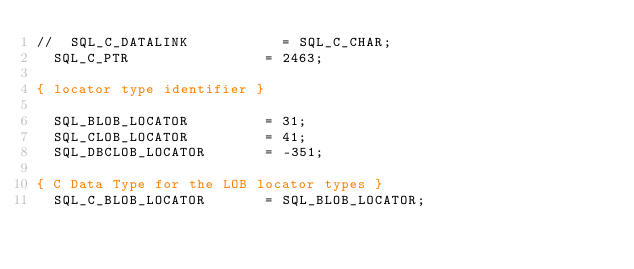Convert code to text. <code><loc_0><loc_0><loc_500><loc_500><_Pascal_>//  SQL_C_DATALINK           = SQL_C_CHAR;
  SQL_C_PTR                = 2463;

{ locator type identifier }

  SQL_BLOB_LOCATOR         = 31;
  SQL_CLOB_LOCATOR         = 41;
  SQL_DBCLOB_LOCATOR       = -351;

{ C Data Type for the LOB locator types }
  SQL_C_BLOB_LOCATOR       = SQL_BLOB_LOCATOR;</code> 